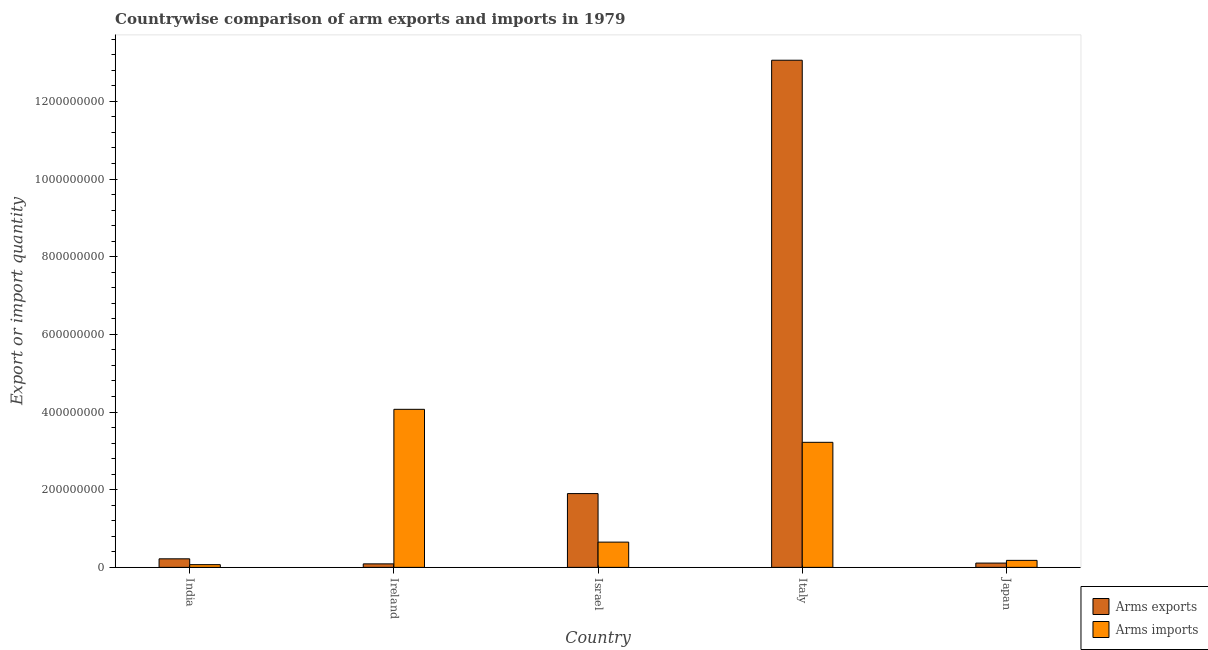What is the label of the 2nd group of bars from the left?
Provide a succinct answer. Ireland. What is the arms exports in India?
Offer a terse response. 2.20e+07. Across all countries, what is the maximum arms exports?
Ensure brevity in your answer.  1.31e+09. Across all countries, what is the minimum arms imports?
Keep it short and to the point. 7.00e+06. In which country was the arms imports maximum?
Offer a very short reply. Ireland. In which country was the arms exports minimum?
Offer a terse response. Ireland. What is the total arms exports in the graph?
Provide a succinct answer. 1.54e+09. What is the difference between the arms exports in India and that in Ireland?
Offer a terse response. 1.30e+07. What is the difference between the arms imports in Japan and the arms exports in Ireland?
Provide a succinct answer. 9.00e+06. What is the average arms exports per country?
Your answer should be compact. 3.08e+08. What is the difference between the arms exports and arms imports in Italy?
Offer a very short reply. 9.84e+08. In how many countries, is the arms imports greater than 680000000 ?
Ensure brevity in your answer.  0. What is the ratio of the arms exports in Israel to that in Japan?
Ensure brevity in your answer.  17.27. Is the difference between the arms exports in India and Japan greater than the difference between the arms imports in India and Japan?
Provide a short and direct response. Yes. What is the difference between the highest and the second highest arms imports?
Your response must be concise. 8.50e+07. What is the difference between the highest and the lowest arms exports?
Offer a very short reply. 1.30e+09. Is the sum of the arms imports in Ireland and Israel greater than the maximum arms exports across all countries?
Your answer should be very brief. No. What does the 1st bar from the left in India represents?
Your answer should be compact. Arms exports. What does the 1st bar from the right in Ireland represents?
Offer a very short reply. Arms imports. What is the difference between two consecutive major ticks on the Y-axis?
Provide a succinct answer. 2.00e+08. Where does the legend appear in the graph?
Give a very brief answer. Bottom right. How many legend labels are there?
Provide a succinct answer. 2. How are the legend labels stacked?
Your response must be concise. Vertical. What is the title of the graph?
Your answer should be very brief. Countrywise comparison of arm exports and imports in 1979. What is the label or title of the Y-axis?
Provide a succinct answer. Export or import quantity. What is the Export or import quantity of Arms exports in India?
Provide a short and direct response. 2.20e+07. What is the Export or import quantity of Arms imports in India?
Your answer should be compact. 7.00e+06. What is the Export or import quantity in Arms exports in Ireland?
Your response must be concise. 9.00e+06. What is the Export or import quantity of Arms imports in Ireland?
Provide a succinct answer. 4.07e+08. What is the Export or import quantity of Arms exports in Israel?
Give a very brief answer. 1.90e+08. What is the Export or import quantity in Arms imports in Israel?
Provide a succinct answer. 6.50e+07. What is the Export or import quantity of Arms exports in Italy?
Ensure brevity in your answer.  1.31e+09. What is the Export or import quantity of Arms imports in Italy?
Your answer should be compact. 3.22e+08. What is the Export or import quantity in Arms exports in Japan?
Provide a short and direct response. 1.10e+07. What is the Export or import quantity of Arms imports in Japan?
Your response must be concise. 1.80e+07. Across all countries, what is the maximum Export or import quantity in Arms exports?
Offer a terse response. 1.31e+09. Across all countries, what is the maximum Export or import quantity in Arms imports?
Provide a short and direct response. 4.07e+08. Across all countries, what is the minimum Export or import quantity in Arms exports?
Offer a terse response. 9.00e+06. What is the total Export or import quantity of Arms exports in the graph?
Offer a very short reply. 1.54e+09. What is the total Export or import quantity of Arms imports in the graph?
Make the answer very short. 8.19e+08. What is the difference between the Export or import quantity in Arms exports in India and that in Ireland?
Ensure brevity in your answer.  1.30e+07. What is the difference between the Export or import quantity in Arms imports in India and that in Ireland?
Make the answer very short. -4.00e+08. What is the difference between the Export or import quantity in Arms exports in India and that in Israel?
Your answer should be very brief. -1.68e+08. What is the difference between the Export or import quantity of Arms imports in India and that in Israel?
Give a very brief answer. -5.80e+07. What is the difference between the Export or import quantity of Arms exports in India and that in Italy?
Provide a succinct answer. -1.28e+09. What is the difference between the Export or import quantity in Arms imports in India and that in Italy?
Your answer should be compact. -3.15e+08. What is the difference between the Export or import quantity of Arms exports in India and that in Japan?
Offer a terse response. 1.10e+07. What is the difference between the Export or import quantity in Arms imports in India and that in Japan?
Provide a short and direct response. -1.10e+07. What is the difference between the Export or import quantity in Arms exports in Ireland and that in Israel?
Make the answer very short. -1.81e+08. What is the difference between the Export or import quantity of Arms imports in Ireland and that in Israel?
Provide a succinct answer. 3.42e+08. What is the difference between the Export or import quantity in Arms exports in Ireland and that in Italy?
Offer a terse response. -1.30e+09. What is the difference between the Export or import quantity of Arms imports in Ireland and that in Italy?
Offer a very short reply. 8.50e+07. What is the difference between the Export or import quantity of Arms exports in Ireland and that in Japan?
Offer a very short reply. -2.00e+06. What is the difference between the Export or import quantity of Arms imports in Ireland and that in Japan?
Provide a short and direct response. 3.89e+08. What is the difference between the Export or import quantity of Arms exports in Israel and that in Italy?
Offer a terse response. -1.12e+09. What is the difference between the Export or import quantity of Arms imports in Israel and that in Italy?
Provide a succinct answer. -2.57e+08. What is the difference between the Export or import quantity in Arms exports in Israel and that in Japan?
Keep it short and to the point. 1.79e+08. What is the difference between the Export or import quantity of Arms imports in Israel and that in Japan?
Make the answer very short. 4.70e+07. What is the difference between the Export or import quantity of Arms exports in Italy and that in Japan?
Your answer should be very brief. 1.30e+09. What is the difference between the Export or import quantity of Arms imports in Italy and that in Japan?
Offer a terse response. 3.04e+08. What is the difference between the Export or import quantity of Arms exports in India and the Export or import quantity of Arms imports in Ireland?
Your answer should be very brief. -3.85e+08. What is the difference between the Export or import quantity in Arms exports in India and the Export or import quantity in Arms imports in Israel?
Give a very brief answer. -4.30e+07. What is the difference between the Export or import quantity in Arms exports in India and the Export or import quantity in Arms imports in Italy?
Give a very brief answer. -3.00e+08. What is the difference between the Export or import quantity of Arms exports in Ireland and the Export or import quantity of Arms imports in Israel?
Provide a succinct answer. -5.60e+07. What is the difference between the Export or import quantity in Arms exports in Ireland and the Export or import quantity in Arms imports in Italy?
Give a very brief answer. -3.13e+08. What is the difference between the Export or import quantity in Arms exports in Ireland and the Export or import quantity in Arms imports in Japan?
Offer a terse response. -9.00e+06. What is the difference between the Export or import quantity in Arms exports in Israel and the Export or import quantity in Arms imports in Italy?
Your answer should be compact. -1.32e+08. What is the difference between the Export or import quantity in Arms exports in Israel and the Export or import quantity in Arms imports in Japan?
Your response must be concise. 1.72e+08. What is the difference between the Export or import quantity of Arms exports in Italy and the Export or import quantity of Arms imports in Japan?
Your answer should be compact. 1.29e+09. What is the average Export or import quantity of Arms exports per country?
Keep it short and to the point. 3.08e+08. What is the average Export or import quantity in Arms imports per country?
Your answer should be compact. 1.64e+08. What is the difference between the Export or import quantity in Arms exports and Export or import quantity in Arms imports in India?
Your response must be concise. 1.50e+07. What is the difference between the Export or import quantity of Arms exports and Export or import quantity of Arms imports in Ireland?
Your response must be concise. -3.98e+08. What is the difference between the Export or import quantity in Arms exports and Export or import quantity in Arms imports in Israel?
Make the answer very short. 1.25e+08. What is the difference between the Export or import quantity of Arms exports and Export or import quantity of Arms imports in Italy?
Make the answer very short. 9.84e+08. What is the difference between the Export or import quantity of Arms exports and Export or import quantity of Arms imports in Japan?
Offer a very short reply. -7.00e+06. What is the ratio of the Export or import quantity in Arms exports in India to that in Ireland?
Your answer should be very brief. 2.44. What is the ratio of the Export or import quantity of Arms imports in India to that in Ireland?
Your answer should be compact. 0.02. What is the ratio of the Export or import quantity in Arms exports in India to that in Israel?
Your answer should be very brief. 0.12. What is the ratio of the Export or import quantity of Arms imports in India to that in Israel?
Your response must be concise. 0.11. What is the ratio of the Export or import quantity of Arms exports in India to that in Italy?
Provide a short and direct response. 0.02. What is the ratio of the Export or import quantity of Arms imports in India to that in Italy?
Your response must be concise. 0.02. What is the ratio of the Export or import quantity of Arms exports in India to that in Japan?
Offer a very short reply. 2. What is the ratio of the Export or import quantity in Arms imports in India to that in Japan?
Offer a very short reply. 0.39. What is the ratio of the Export or import quantity of Arms exports in Ireland to that in Israel?
Keep it short and to the point. 0.05. What is the ratio of the Export or import quantity in Arms imports in Ireland to that in Israel?
Offer a terse response. 6.26. What is the ratio of the Export or import quantity of Arms exports in Ireland to that in Italy?
Make the answer very short. 0.01. What is the ratio of the Export or import quantity of Arms imports in Ireland to that in Italy?
Your answer should be very brief. 1.26. What is the ratio of the Export or import quantity in Arms exports in Ireland to that in Japan?
Make the answer very short. 0.82. What is the ratio of the Export or import quantity of Arms imports in Ireland to that in Japan?
Offer a terse response. 22.61. What is the ratio of the Export or import quantity of Arms exports in Israel to that in Italy?
Provide a short and direct response. 0.15. What is the ratio of the Export or import quantity of Arms imports in Israel to that in Italy?
Offer a very short reply. 0.2. What is the ratio of the Export or import quantity in Arms exports in Israel to that in Japan?
Your response must be concise. 17.27. What is the ratio of the Export or import quantity in Arms imports in Israel to that in Japan?
Provide a short and direct response. 3.61. What is the ratio of the Export or import quantity of Arms exports in Italy to that in Japan?
Provide a short and direct response. 118.73. What is the ratio of the Export or import quantity in Arms imports in Italy to that in Japan?
Offer a terse response. 17.89. What is the difference between the highest and the second highest Export or import quantity in Arms exports?
Keep it short and to the point. 1.12e+09. What is the difference between the highest and the second highest Export or import quantity in Arms imports?
Your answer should be very brief. 8.50e+07. What is the difference between the highest and the lowest Export or import quantity in Arms exports?
Keep it short and to the point. 1.30e+09. What is the difference between the highest and the lowest Export or import quantity in Arms imports?
Provide a short and direct response. 4.00e+08. 